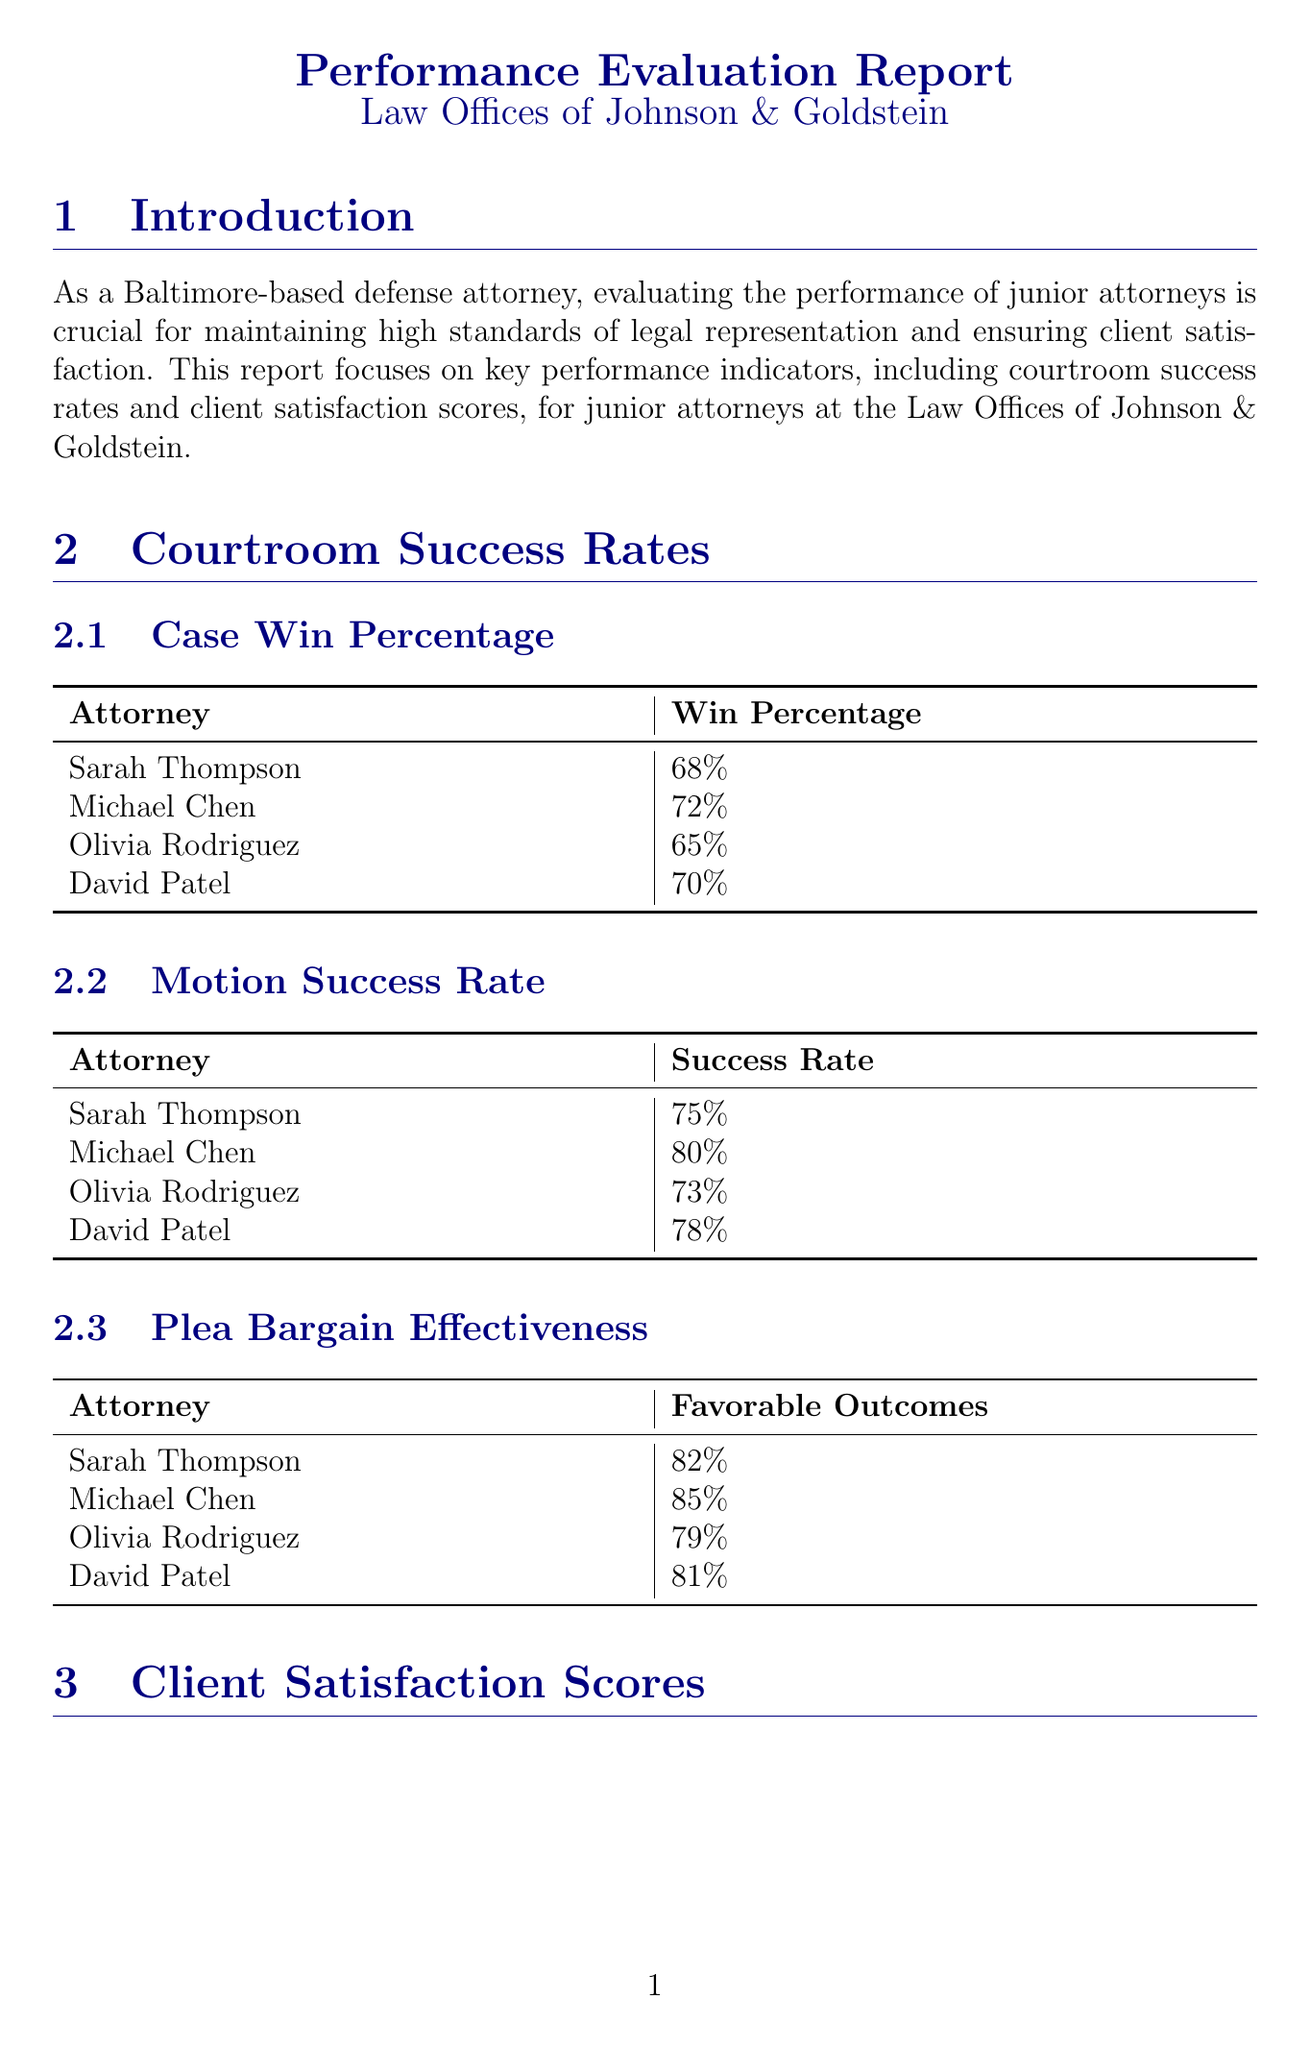What is the case win percentage for Michael Chen? The case win percentage for Michael Chen is listed in the "Case Win Percentage" subsection, which shows a value of 72%.
Answer: 72% What is Sarah Thompson's overall client satisfaction score? The overall client satisfaction score for Sarah Thompson is mentioned in the "Overall Satisfaction (out of 5)" subsection, which indicates a score of 4.2.
Answer: 4.2 Which attorney has the highest motion success rate? The motion success rates for each attorney are detailed, and Michael Chen has the highest rate at 80%.
Answer: Michael Chen How many active cases is Olivia Rodriguez currently managing? The number of active cases each attorney is managing is provided, showing that Olivia Rodriguez is managing 26 active cases.
Answer: 26 Which area of improvement is suggested for all junior attorneys? The areas for improvement section identifies a specific skill to enhance, which is motion writing skills.
Answer: Motion writing skills What percentage of favorable outcomes does David Patel achieve in plea bargains? The data in the "Plea Bargain Effectiveness" subsection states that David Patel has 81% favorable outcomes in plea bargains.
Answer: 81% What is the communication effectiveness score for Michael Chen? Michael Chen's communication effectiveness score is found in the corresponding subsection, showing a score of 4.6.
Answer: 4.6 What feedback was given about Olivia Rodriguez during peer reviews? Peer review feedback for Olivia Rodriguez highlights her strengths and weaknesses, mentioning her great client rapport and need to work on time management.
Answer: Great client rapport, needs to work on time management What is the required amount of continuing legal education hours for junior attorneys? The professional development section specifies that junior attorneys must complete 12 hours of Continuing Legal Education annually.
Answer: 12 hours 